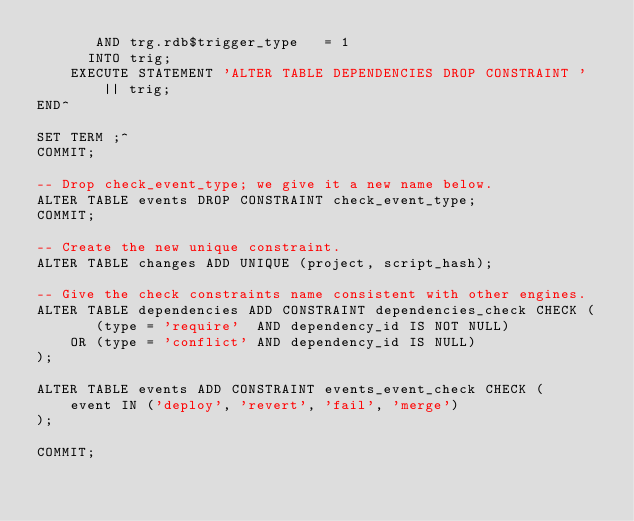Convert code to text. <code><loc_0><loc_0><loc_500><loc_500><_SQL_>       AND trg.rdb$trigger_type   = 1
      INTO trig;
    EXECUTE STATEMENT 'ALTER TABLE DEPENDENCIES DROP CONSTRAINT ' || trig;
END^

SET TERM ;^
COMMIT;

-- Drop check_event_type; we give it a new name below.
ALTER TABLE events DROP CONSTRAINT check_event_type;
COMMIT;

-- Create the new unique constraint.
ALTER TABLE changes ADD UNIQUE (project, script_hash);

-- Give the check constraints name consistent with other engines.
ALTER TABLE dependencies ADD CONSTRAINT dependencies_check CHECK (
       (type = 'require'  AND dependency_id IS NOT NULL)
    OR (type = 'conflict' AND dependency_id IS NULL)
);

ALTER TABLE events ADD CONSTRAINT events_event_check CHECK (
    event IN ('deploy', 'revert', 'fail', 'merge')
);

COMMIT;
</code> 